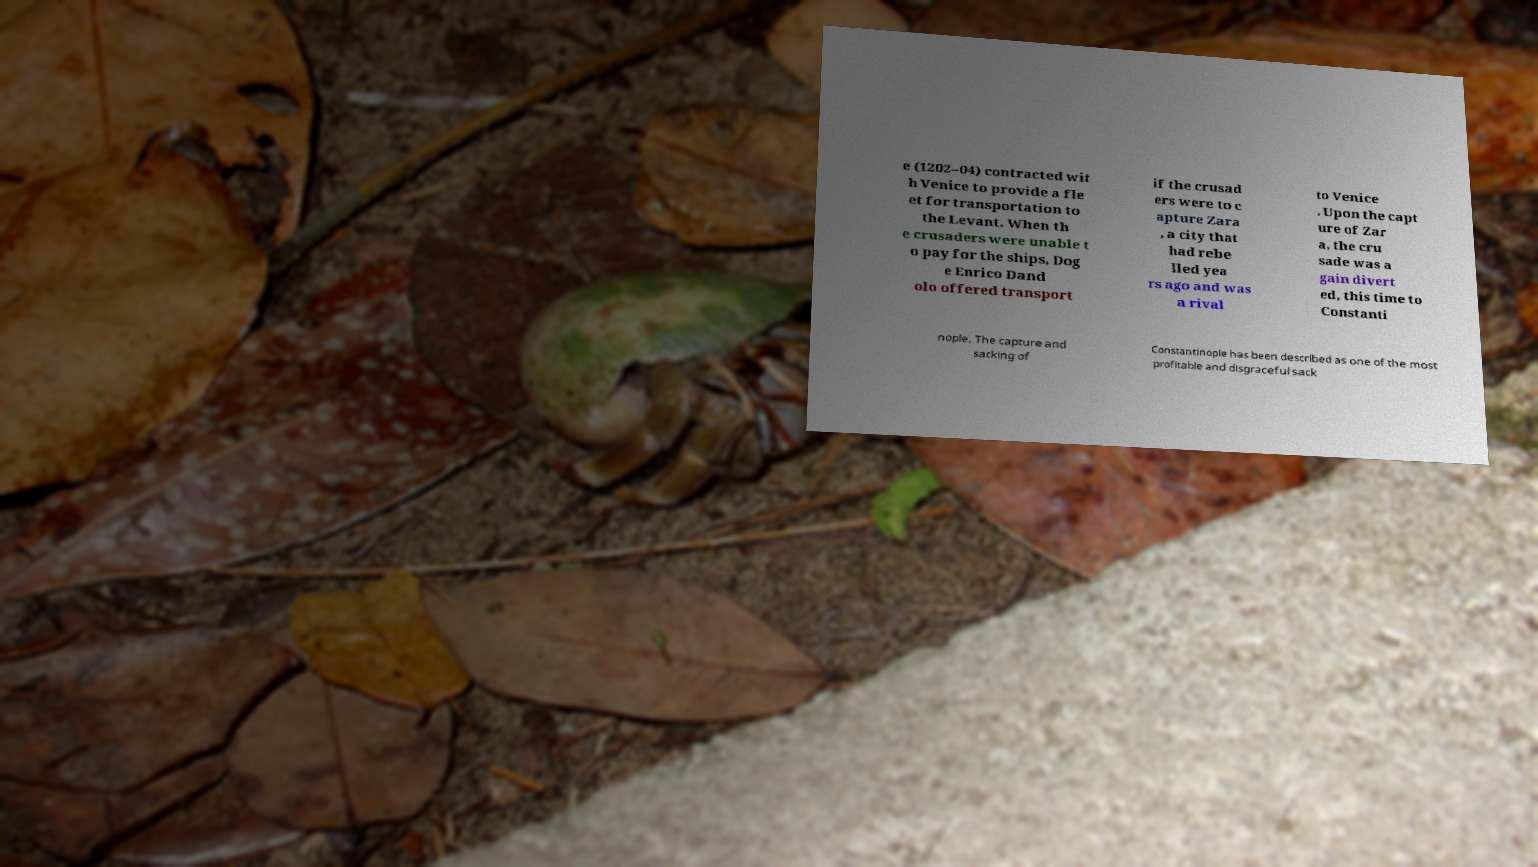Could you extract and type out the text from this image? e (1202–04) contracted wit h Venice to provide a fle et for transportation to the Levant. When th e crusaders were unable t o pay for the ships, Dog e Enrico Dand olo offered transport if the crusad ers were to c apture Zara , a city that had rebe lled yea rs ago and was a rival to Venice . Upon the capt ure of Zar a, the cru sade was a gain divert ed, this time to Constanti nople. The capture and sacking of Constantinople has been described as one of the most profitable and disgraceful sack 